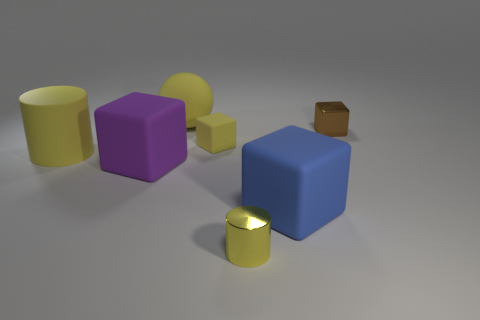Add 1 small yellow objects. How many objects exist? 8 Subtract all blocks. How many objects are left? 3 Add 7 small brown metallic cubes. How many small brown metallic cubes are left? 8 Add 5 large yellow cylinders. How many large yellow cylinders exist? 6 Subtract 0 cyan balls. How many objects are left? 7 Subtract all big spheres. Subtract all matte cubes. How many objects are left? 3 